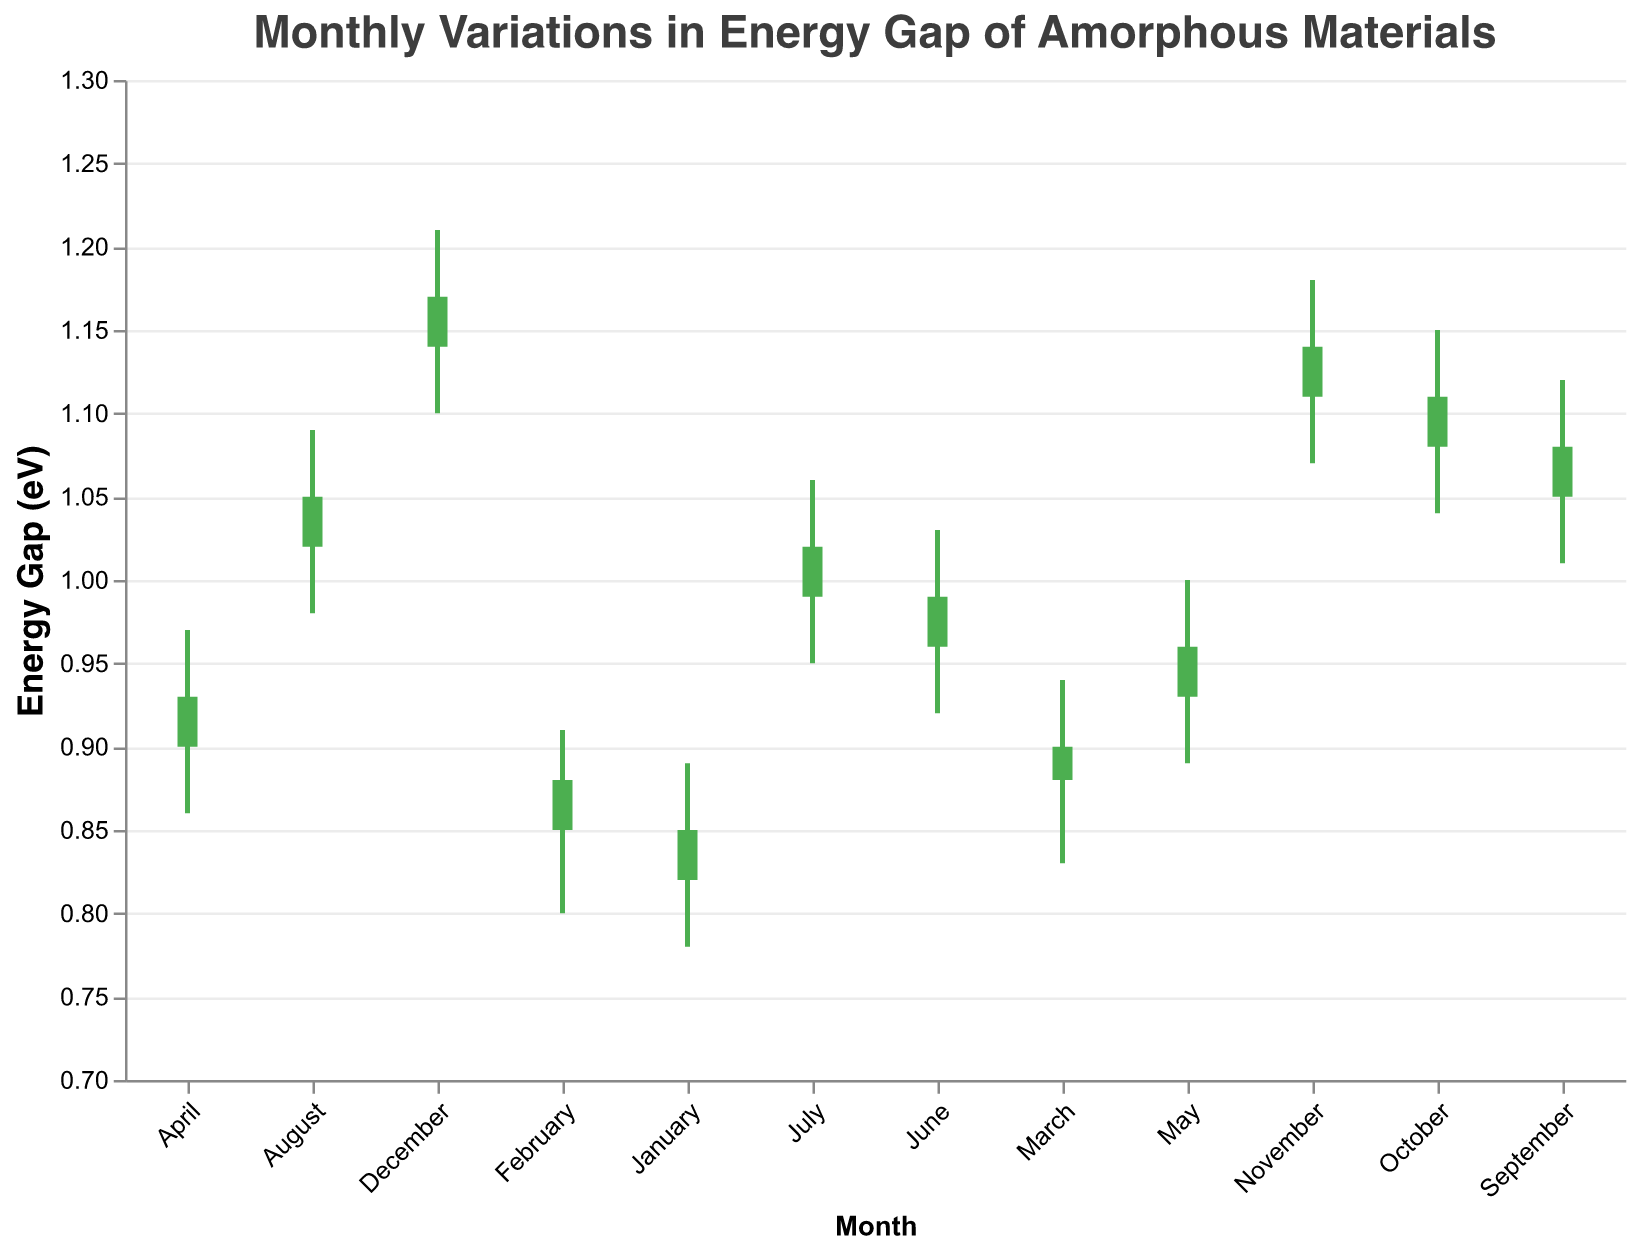What is the title of the chart? The title is displayed at the top of the chart and reads "Monthly Variations in Energy Gap of Amorphous Materials".
Answer: Monthly Variations in Energy Gap of Amorphous Materials Which month shows the highest high value for the energy gap? Observing the high values for each month, December has the highest value at 1.21 eV.
Answer: December What is the range of energy gap values in July (difference between High and Low)? The High value in July is 1.06 and the Low value is 0.95. The range is calculated as the difference between High and Low values: 1.06 - 0.95 = 0.11 eV.
Answer: 0.11 eV In which month does the energy gap close higher than it opens? The Close value is higher than the Open value if the bar is colored green. These months are January, February, March, April, May, June, July, August, September, October, November, December.
Answer: All months What is the median Closing value for the first six months? The Closing values for January to June are 0.85, 0.88, 0.90, 0.93, 0.96, and 0.99. Arranging these values in order: 0.85, 0.88, 0.90, 0.93, 0.96, 0.99. The median is the average of the 3rd and 4th values: (0.90 + 0.93) / 2 = 0.915 eV.
Answer: 0.915 eV Comparing March and October, which month has a greater volatility in energy gap? Volatility can be measured by the range (High - Low). For March, the range is 0.94 - 0.83 = 0.11 eV. For October, the range is 1.15 - 1.04 = 0.11 eV. Since both ranges are equal, the volatility is the same.
Answer: Equal Which month shows the smallest difference between the Open and Close values? The difference between Open and Close is smallest in March (0.90 - 0.88 = 0.02 eV).
Answer: March What is the average High value across all months? Summing the High values: 0.89 + 0.91 + 0.94 + 0.97 + 1.00 + 1.03 + 1.06 + 1.09 + 1.12 + 1.15 + 1.18 + 1.21 = 12.55 eV. The average is 12.55 / 12 = 1.046 eV.
Answer: 1.046 eV Which month saw the lowest Close value? Observing the Close values, January has the lowest Close value at 0.85 eV.
Answer: January In which month does the energy gap open at its highest value? The highest Open value is in December at 1.14 eV.
Answer: December 